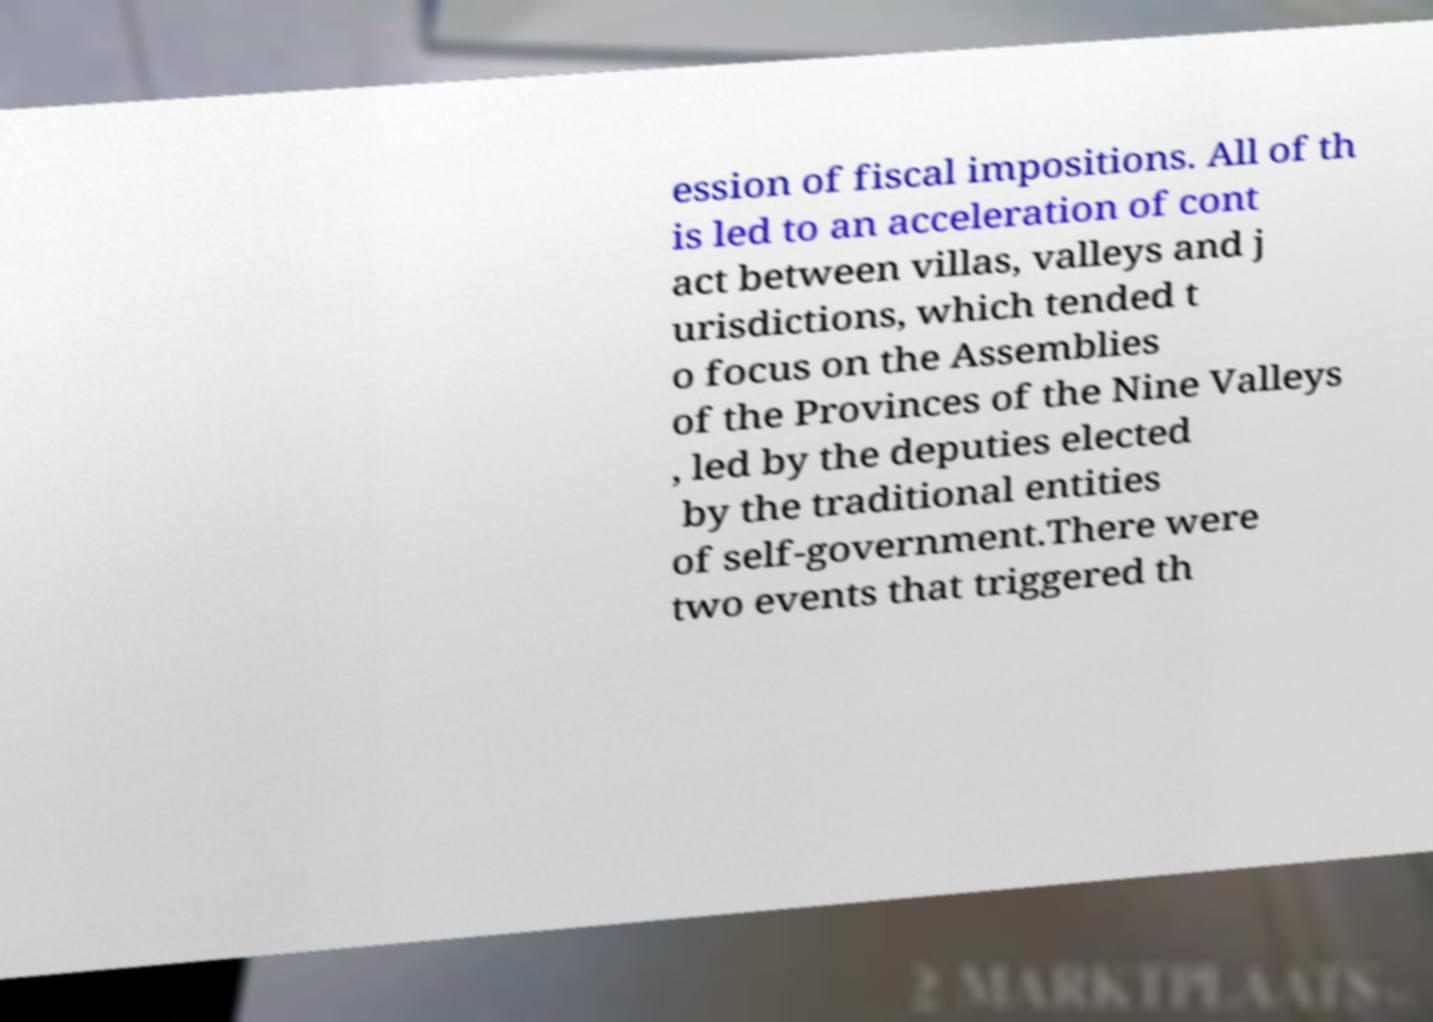What messages or text are displayed in this image? I need them in a readable, typed format. ession of fiscal impositions. All of th is led to an acceleration of cont act between villas, valleys and j urisdictions, which tended t o focus on the Assemblies of the Provinces of the Nine Valleys , led by the deputies elected by the traditional entities of self-government.There were two events that triggered th 